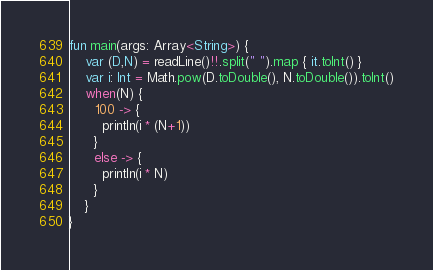<code> <loc_0><loc_0><loc_500><loc_500><_Kotlin_>fun main(args: Array<String>) {
    var (D,N) = readLine()!!.split(" ").map { it.toInt() }
    var i: Int = Math.pow(D.toDouble(), N.toDouble()).toInt()
  	when(N) {
      100 -> {
        println(i * (N+1))
      }
      else -> {
        println(i * N)
      }   
    }	
}</code> 